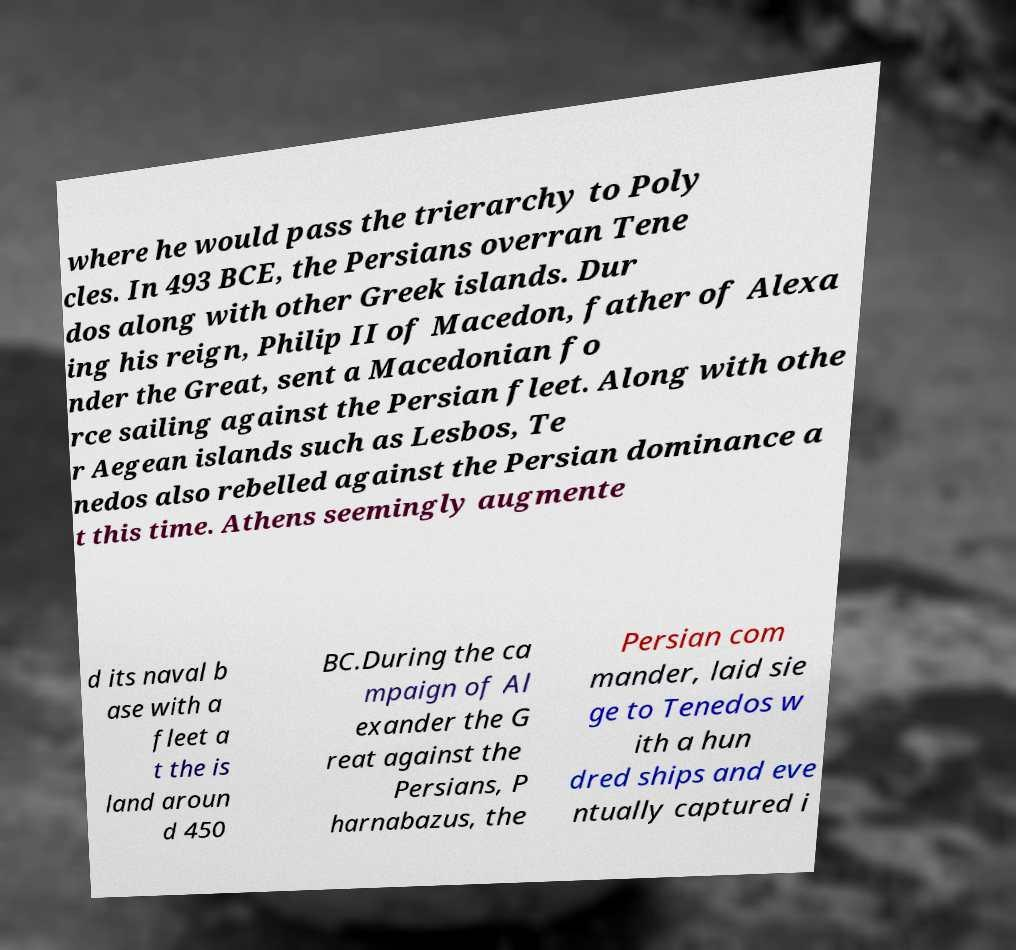Please identify and transcribe the text found in this image. where he would pass the trierarchy to Poly cles. In 493 BCE, the Persians overran Tene dos along with other Greek islands. Dur ing his reign, Philip II of Macedon, father of Alexa nder the Great, sent a Macedonian fo rce sailing against the Persian fleet. Along with othe r Aegean islands such as Lesbos, Te nedos also rebelled against the Persian dominance a t this time. Athens seemingly augmente d its naval b ase with a fleet a t the is land aroun d 450 BC.During the ca mpaign of Al exander the G reat against the Persians, P harnabazus, the Persian com mander, laid sie ge to Tenedos w ith a hun dred ships and eve ntually captured i 